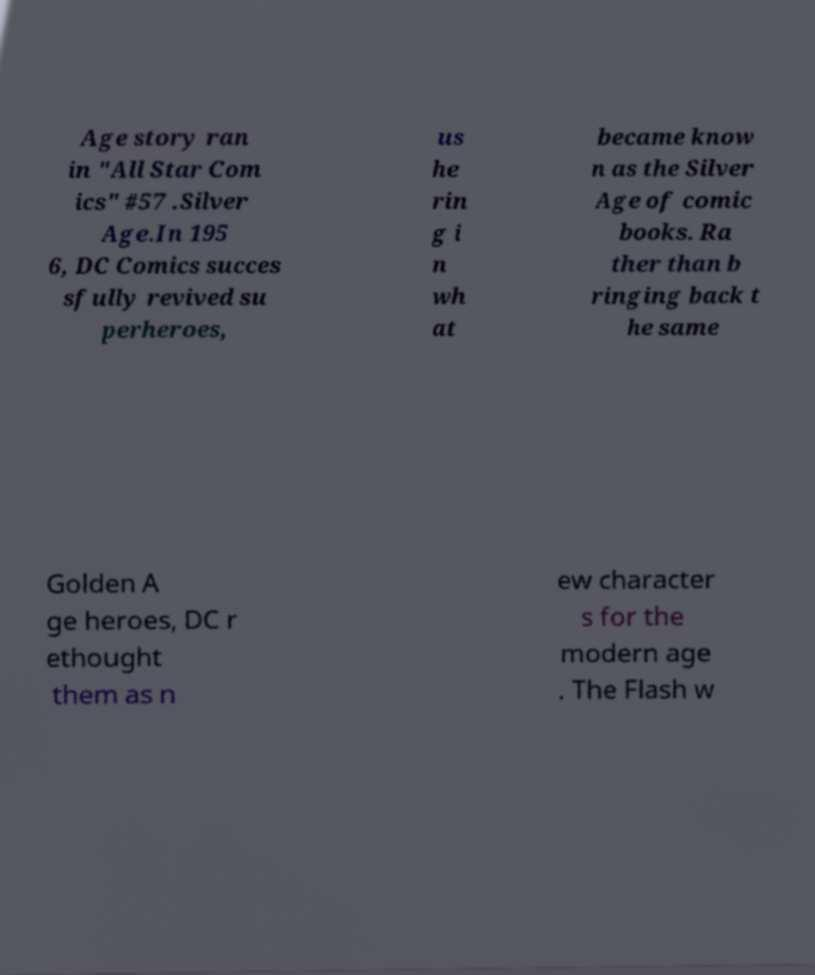What messages or text are displayed in this image? I need them in a readable, typed format. Age story ran in "All Star Com ics" #57 .Silver Age.In 195 6, DC Comics succes sfully revived su perheroes, us he rin g i n wh at became know n as the Silver Age of comic books. Ra ther than b ringing back t he same Golden A ge heroes, DC r ethought them as n ew character s for the modern age . The Flash w 